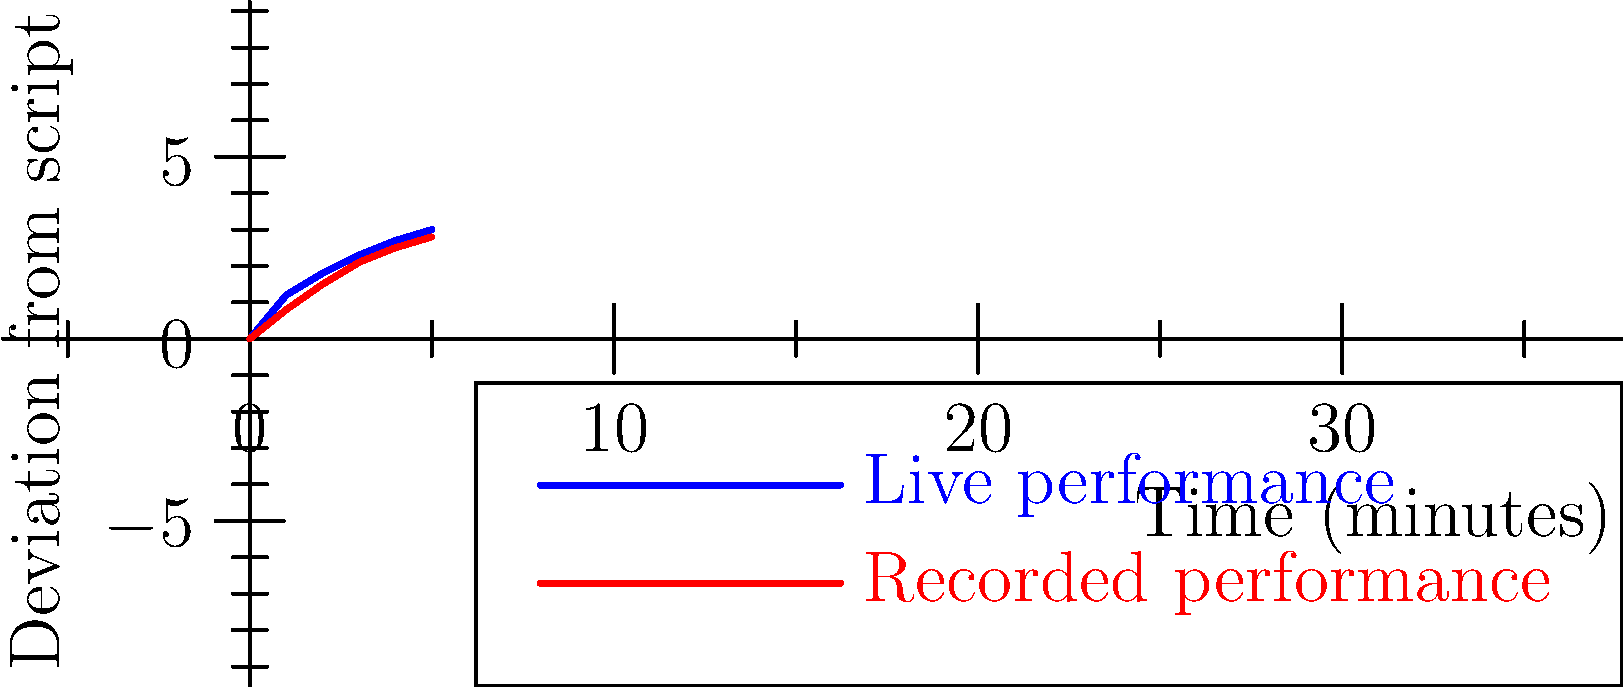Based on the speech-to-text visualization comparing live and recorded performances, what is the approximate difference in script deviation between the two types of performances at the 3-minute mark? To answer this question, we need to follow these steps:

1. Identify the 3-minute mark on the x-axis (Time).
2. Find the corresponding y-values (Deviation from script) for both live and recorded performances at this point.
3. Calculate the difference between these two values.

Step 1: The 3-minute mark is clearly visible on the x-axis.

Step 2: 
- For the live performance (blue line), the deviation at 3 minutes is approximately 2.3.
- For the recorded performance (red line), the deviation at 3 minutes is approximately 2.1.

Step 3: Calculate the difference
$2.3 - 2.1 = 0.2$

Therefore, the approximate difference in script deviation between live and recorded performances at the 3-minute mark is 0.2.
Answer: 0.2 